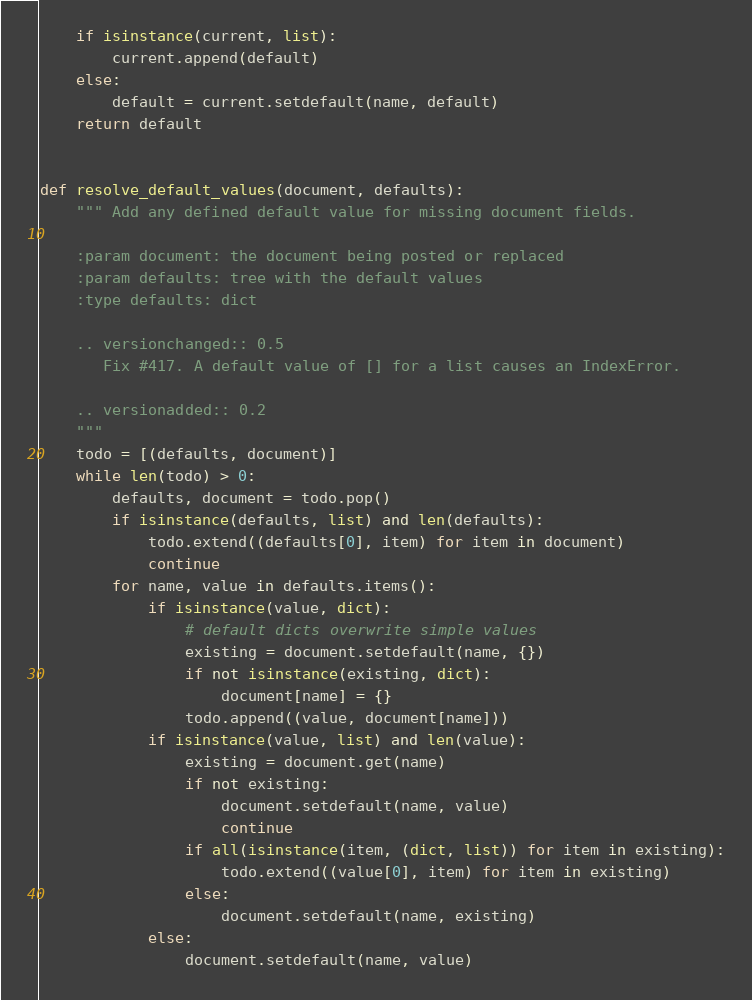Convert code to text. <code><loc_0><loc_0><loc_500><loc_500><_Python_>    if isinstance(current, list):
        current.append(default)
    else:
        default = current.setdefault(name, default)
    return default


def resolve_default_values(document, defaults):
    """ Add any defined default value for missing document fields.

    :param document: the document being posted or replaced
    :param defaults: tree with the default values
    :type defaults: dict

    .. versionchanged:: 0.5
       Fix #417. A default value of [] for a list causes an IndexError.

    .. versionadded:: 0.2
    """
    todo = [(defaults, document)]
    while len(todo) > 0:
        defaults, document = todo.pop()
        if isinstance(defaults, list) and len(defaults):
            todo.extend((defaults[0], item) for item in document)
            continue
        for name, value in defaults.items():
            if isinstance(value, dict):
                # default dicts overwrite simple values
                existing = document.setdefault(name, {})
                if not isinstance(existing, dict):
                    document[name] = {}
                todo.append((value, document[name]))
            if isinstance(value, list) and len(value):
                existing = document.get(name)
                if not existing:
                    document.setdefault(name, value)
                    continue
                if all(isinstance(item, (dict, list)) for item in existing):
                    todo.extend((value[0], item) for item in existing)
                else:
                    document.setdefault(name, existing)
            else:
                document.setdefault(name, value)
</code> 